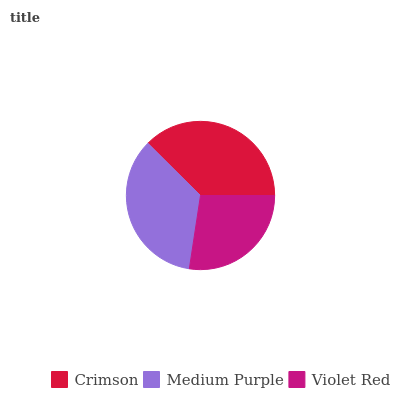Is Violet Red the minimum?
Answer yes or no. Yes. Is Crimson the maximum?
Answer yes or no. Yes. Is Medium Purple the minimum?
Answer yes or no. No. Is Medium Purple the maximum?
Answer yes or no. No. Is Crimson greater than Medium Purple?
Answer yes or no. Yes. Is Medium Purple less than Crimson?
Answer yes or no. Yes. Is Medium Purple greater than Crimson?
Answer yes or no. No. Is Crimson less than Medium Purple?
Answer yes or no. No. Is Medium Purple the high median?
Answer yes or no. Yes. Is Medium Purple the low median?
Answer yes or no. Yes. Is Violet Red the high median?
Answer yes or no. No. Is Crimson the low median?
Answer yes or no. No. 